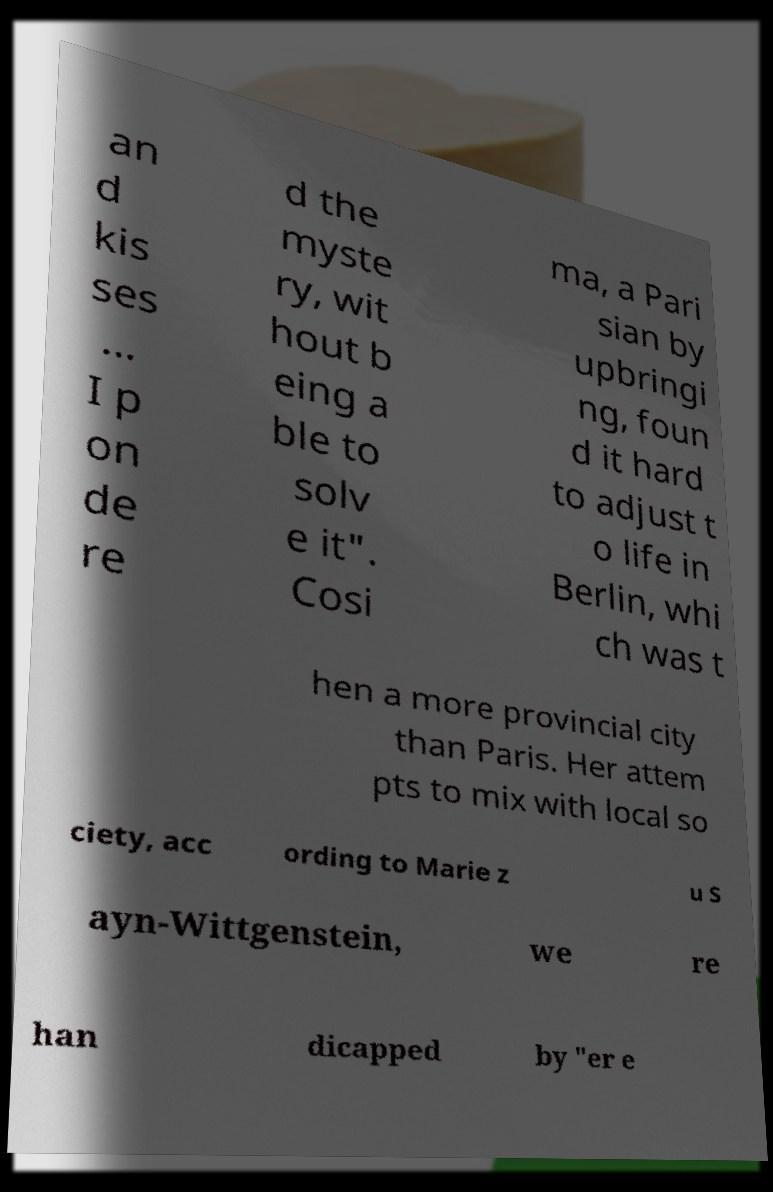Please identify and transcribe the text found in this image. an d kis ses ... I p on de re d the myste ry, wit hout b eing a ble to solv e it". Cosi ma, a Pari sian by upbringi ng, foun d it hard to adjust t o life in Berlin, whi ch was t hen a more provincial city than Paris. Her attem pts to mix with local so ciety, acc ording to Marie z u S ayn-Wittgenstein, we re han dicapped by "er e 